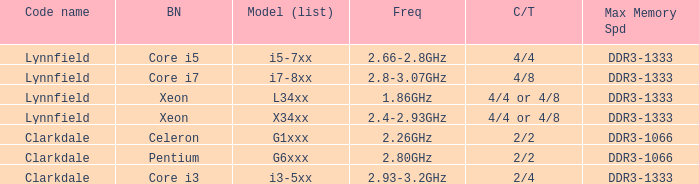What is the maximum memory speed for frequencies between 2.93-3.2ghz? DDR3-1333. 